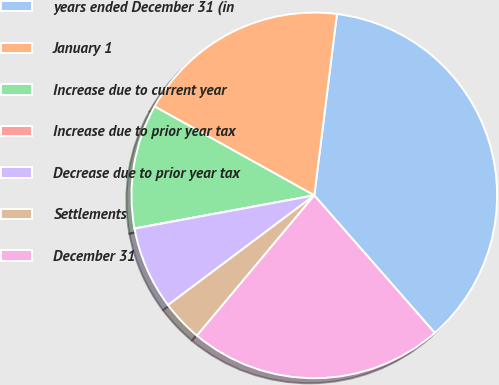Convert chart. <chart><loc_0><loc_0><loc_500><loc_500><pie_chart><fcel>years ended December 31 (in<fcel>January 1<fcel>Increase due to current year<fcel>Increase due to prior year tax<fcel>Decrease due to prior year tax<fcel>Settlements<fcel>December 31<nl><fcel>36.57%<fcel>18.89%<fcel>10.98%<fcel>0.02%<fcel>7.33%<fcel>3.67%<fcel>22.54%<nl></chart> 